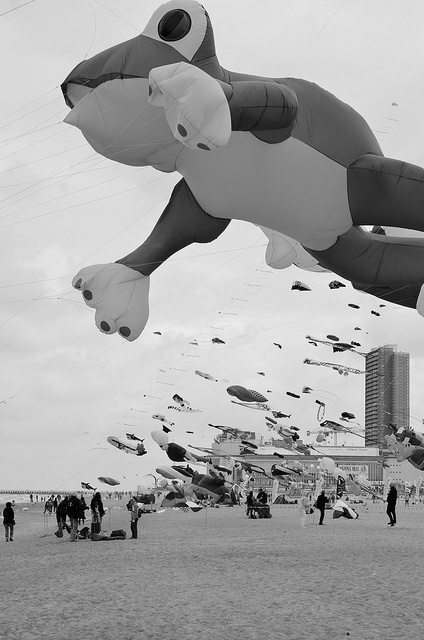Describe the objects in this image and their specific colors. I can see kite in lightgray, gray, and black tones, kite in lightgray, darkgray, gray, and black tones, people in lightgray, darkgray, gray, and black tones, people in black, gray, darkgray, and lightgray tones, and kite in lightgray, darkgray, gray, and black tones in this image. 